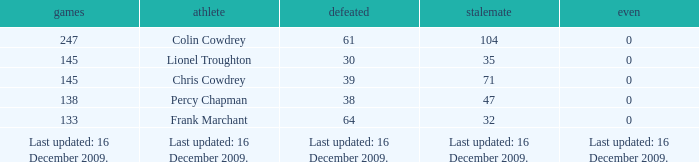I want to know the tie for drawn of 47 0.0. 